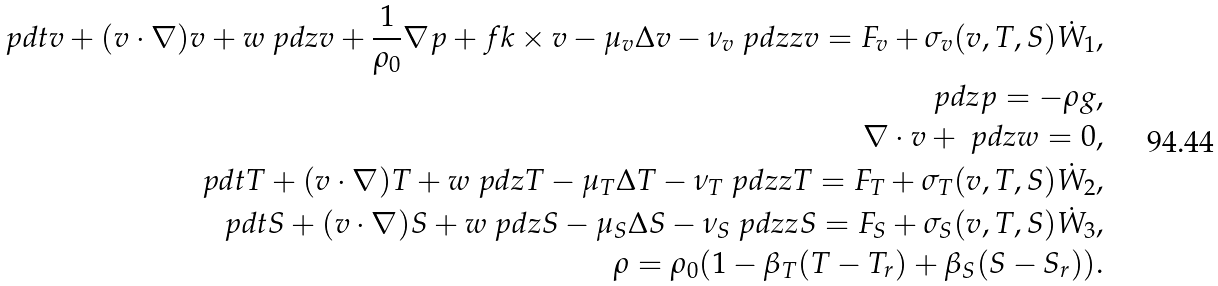Convert formula to latex. <formula><loc_0><loc_0><loc_500><loc_500>\ p d { t } v + ( v \cdot \nabla ) v + w \ p d { z } v + \frac { 1 } { \rho _ { 0 } } \nabla p + f k \times v - \mu _ { v } \Delta v - \nu _ { v } \ p d { z z } v = F _ { v } + \sigma _ { v } ( v , T , S ) \dot { W } _ { 1 } , \\ \ p d { z } p = - \rho g , \\ \nabla \cdot v + \ p d { z } w = 0 , \\ \ p d { t } T + ( v \cdot \nabla ) T + w \ p d { z } T - \mu _ { T } \Delta T - \nu _ { T } \ p d { z z } T = F _ { T } + \sigma _ { T } ( v , T , S ) \dot { W } _ { 2 } , \\ \ p d { t } S + ( v \cdot \nabla ) S + w \ p d { z } S - \mu _ { S } \Delta S - \nu _ { S } \ p d { z z } S = F _ { S } + \sigma _ { S } ( v , T , S ) \dot { W } _ { 3 } , \\ \rho = \rho _ { 0 } ( 1 - \beta _ { T } ( T - T _ { r } ) + \beta _ { S } ( S - S _ { r } ) ) .</formula> 